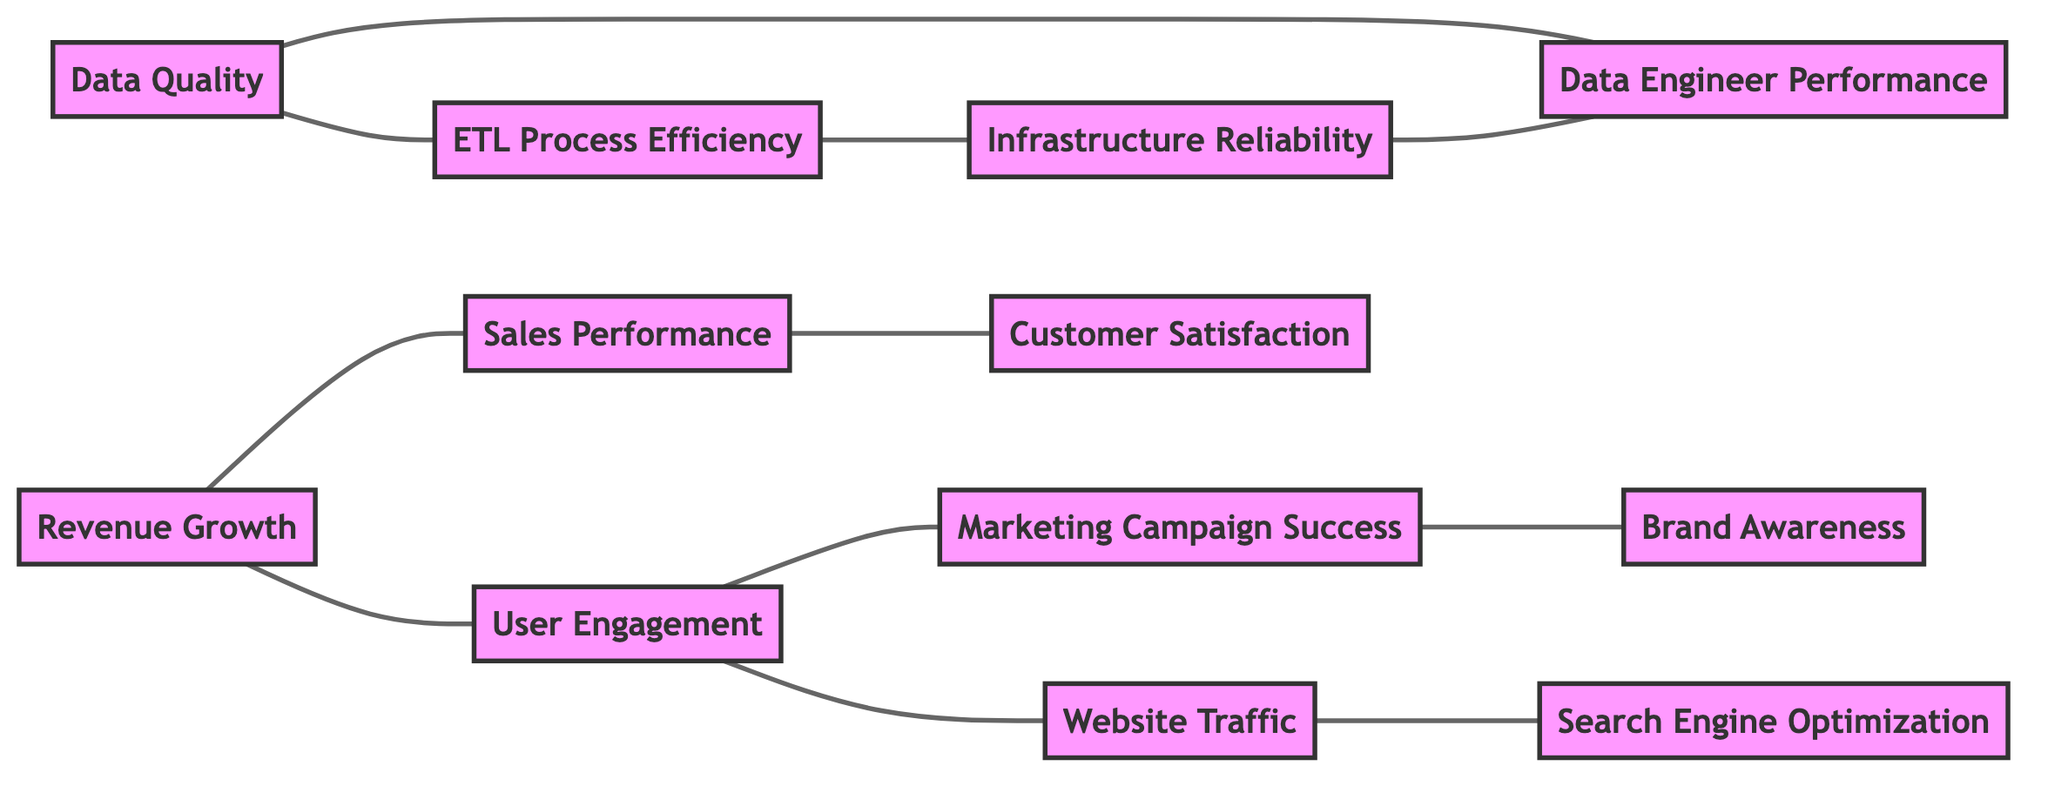What are the connections of Data Quality? The diagram shows that Data Quality has connections with two other KPIs: Data Engineer Performance and ETL Process Efficiency. This can be observed from the lines connecting Data Quality to these nodes.
Answer: Data Engineer Performance, ETL Process Efficiency Which KPI is directly connected to Website Traffic? According to the diagram, Website Traffic is connected to two KPIs: User Engagement and Search Engine Optimization. The connections can be seen as lines leading from Website Traffic to these two other KPI nodes.
Answer: User Engagement, Search Engine Optimization How many KPIs are connected to Revenue Growth? By examining the diagram, Revenue Growth has two direct connections: Sales Performance and User Engagement. This means that there are a total of two nodes that connect to Revenue Growth.
Answer: 2 What KPI influences Sales Performance? The diagram indicates that Sales Performance is influenced by two KPIs: Revenue Growth and Customer Satisfaction. This influence is evident from the lines connecting Sales Performance to these KPIs.
Answer: Revenue Growth, Customer Satisfaction Which KPI is a connection point between User Engagement and Marketing Campaign Success? The diagram shows that User Engagement connects to Revenue Growth, which is influenced by User Engagement and Sales Performance. Hence, the connection point is User Engagement, as it influences Marketing Campaign Success through User Engagement itself.
Answer: User Engagement What is the total number of KPIs represented in the diagram? Upon reviewing the diagram, there are a total of twelve distinct KPIs present in the graph. Each KPI can be counted individually from the nodes listed.
Answer: 12 What KPI connects ETL Process Efficiency and Infrastructure Reliability? The diagram shows that ETL Process Efficiency is connected to Data Quality and Infrastructure Reliability; hence, Infrastructure Reliability is the KPI that serves as a connecting point.
Answer: Infrastructure Reliability Which KPI indirectly influences Data Quality through its connection? Following the paths in the diagram, Data Quality is indirectly influenced by Infrastructure Reliability through ETL Process Efficiency, as evidenced by the connections between these KPIs in the graph.
Answer: Infrastructure Reliability What is the relationship between Brand Awareness and Marketing Campaign Success? According to the diagram, Brand Awareness is directly connected to Marketing Campaign Success, indicating that changes in Brand Awareness can impact the success of a marketing campaign.
Answer: Direct connection 